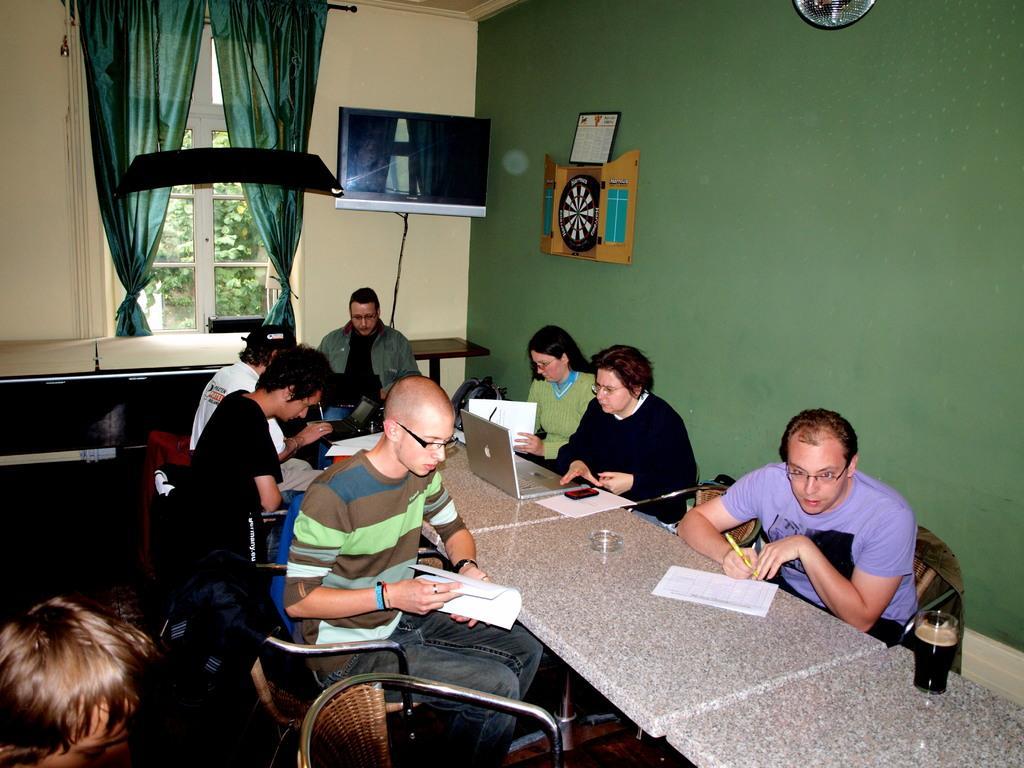Could you give a brief overview of what you see in this image? There are many persons sitting in the room. A short person is holding a pen. And there are tables. On the table there is laptop, papers, mobile and glasses. In the background there is a wall, TV, curtains and a wall , photo frame. 